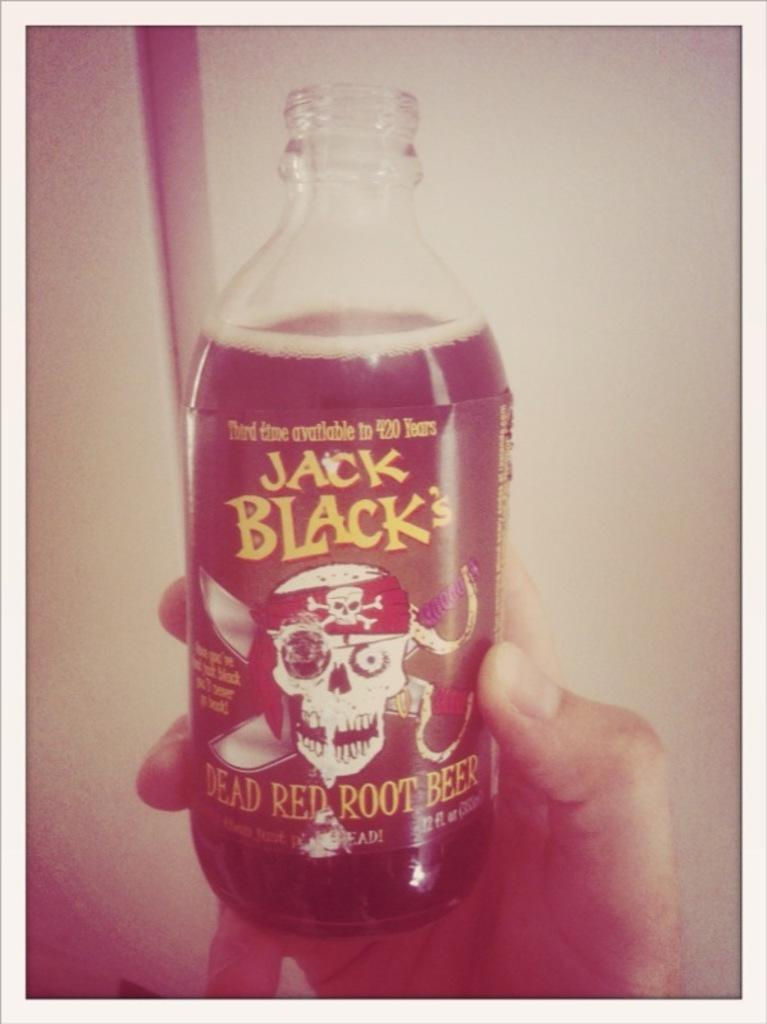<image>
Provide a brief description of the given image. Hand holding a can of Jack Black Dead Red Root Beer 